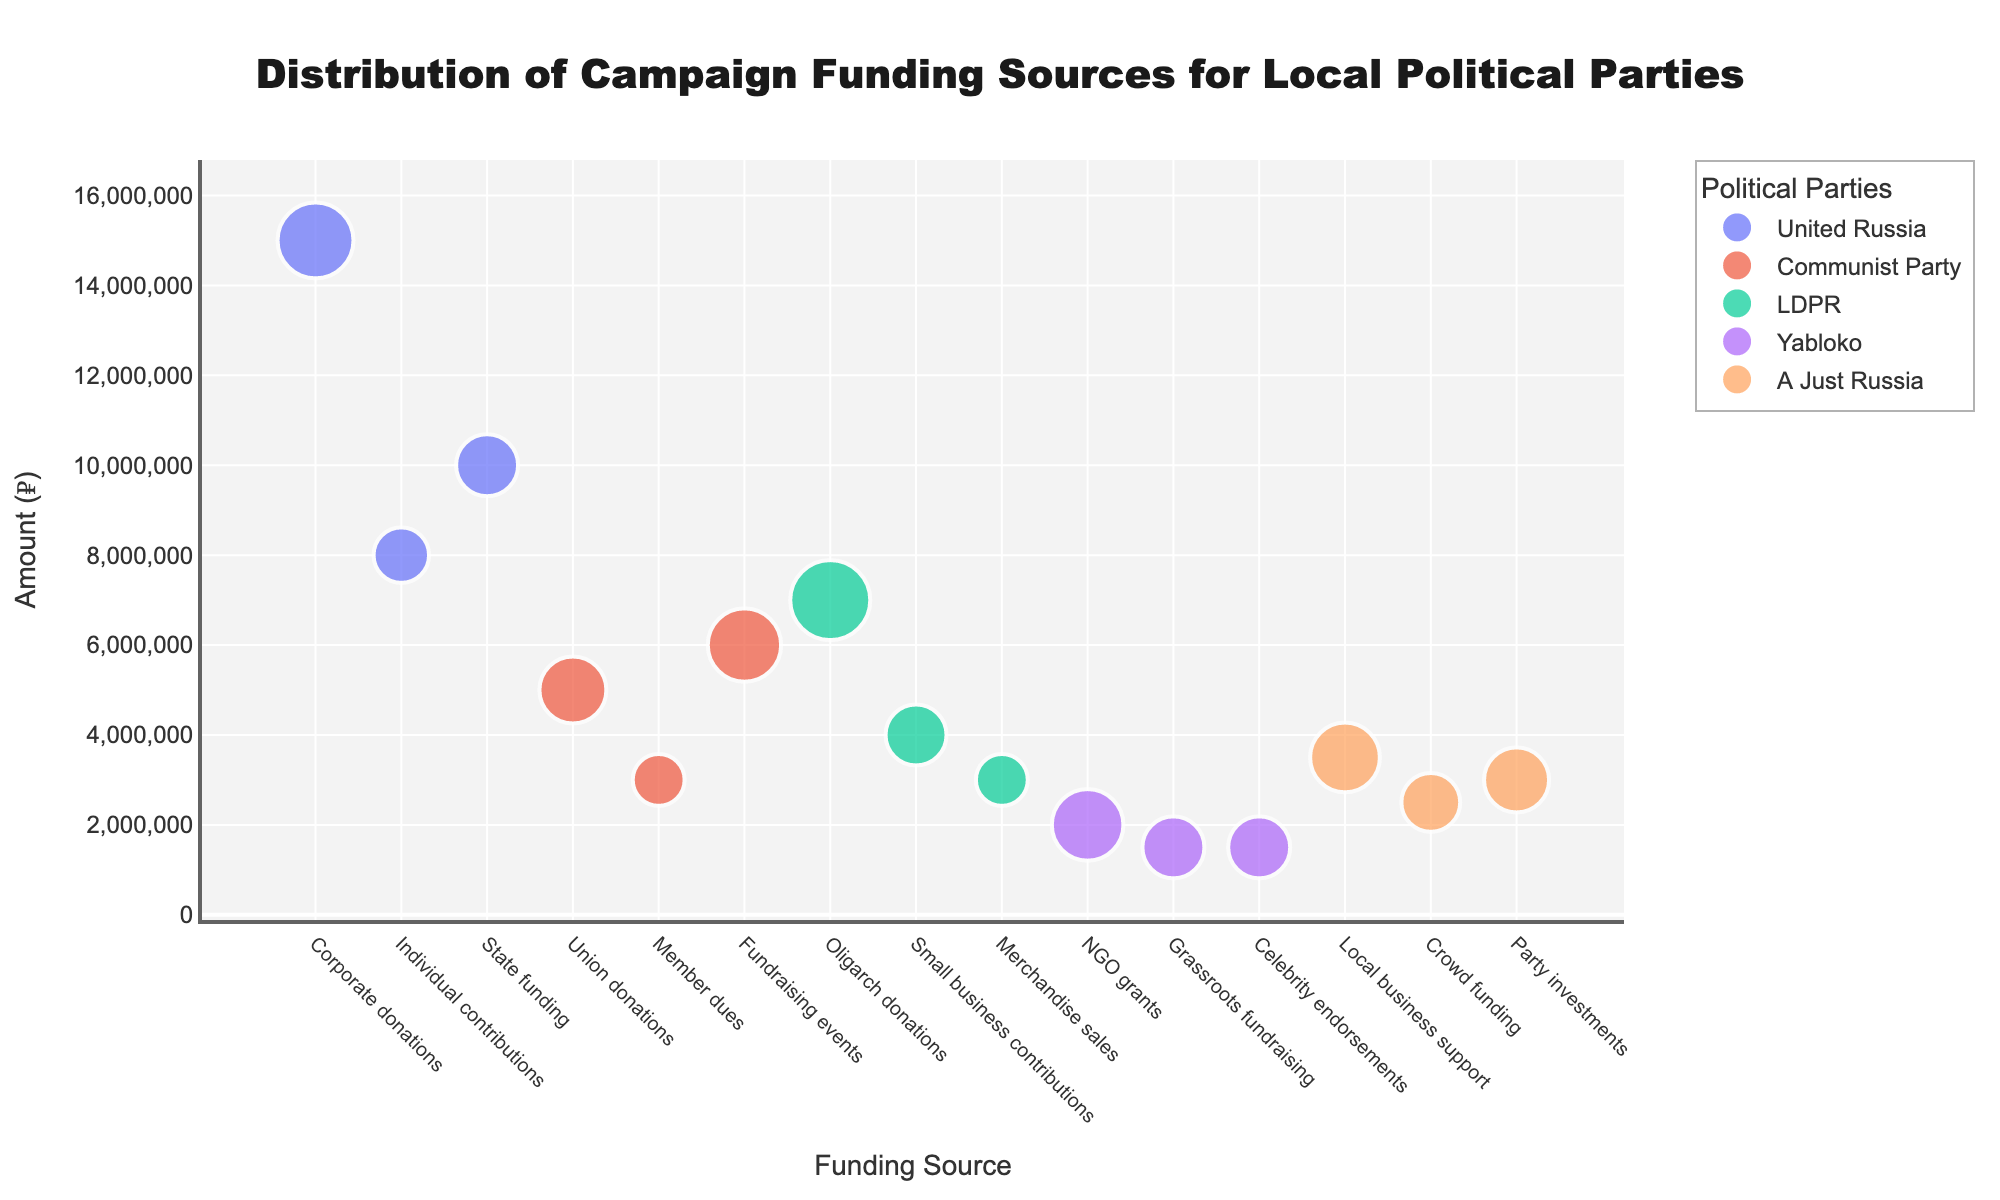what is the title of the figure? The title is displayed prominently at the top of the figure, usually in bold text.
Answer: Distribution of Campaign Funding Sources for Local Political Parties Which political party has the largest percentage of funding from a single source? Looking at the bubble sizes, the largest percentages are 50% for LDPR (Oligarch donations) and 45% for United Russia (Corporate donations). Comparing these, 50% is larger.
Answer: LDPR How many funding sources are listed for United Russia? Counting the number of unique bubbles for "United Russia" on the x-axis gives this information.
Answer: 3 What is the amount of the smallest funding source for Yabloko? Observing the bubbles for Yabloko, the one with the smallest amount is labeled as "₽1,500,000".
Answer: ₽1,500,000 Which funding source has the highest amount for the Communist Party? Examining the y-axis values for each bubble associated with the Communist Party, the highest one is "Fundraising events" at ₽6,000,000.
Answer: Fundraising events What's the sum of the amounts for all funding sources of A Just Russia? Adding up the amounts for Local business support (₽3,500,000), Crowd funding (₽2,500,000), and Party investments (₽3,000,000): 3,500,000 + 2,500,000 + 3,000,000.
Answer: ₽9,000,000 Which party relies most on small businesses for funding? Looking at the funding source labels and identifying which party has "Small business contributions", it is LDPR with an amount of ₽4,000,000.
Answer: LDPR What is the relative size of the percentages for the sources of Yabloko's funding? Observing the bubble sizes and their labels for Yabloko, the sources are 40% for NGO grants, 30% for Grassroots fundraising, and 30% for Celebrity endorsements.
Answer: 40%, 30%, 30% Which party has the smallest total funding based on the amounts shown? Adding up the amounts for each party and comparing totals: 
United Russia: 15,000,000 + 8,000,000 + 10,000,000 = 33,000,000.
Communist Party: 5,000,000 + 3,000,000 + 6,000,000 = 14,000,000.
LDPR: 7,000,000 + 4,000,000 + 3,000,000 = 14,000,000.
Yabloko: 2,000,000 + 1,500,000 + 1,500,000 = 5,000,000.
A Just Russia: 3,500,000 + 2,500,000 + 3,000,000 = 9,000,000. 
Thus, Yabloko has the smallest total.
Answer: Yabloko 